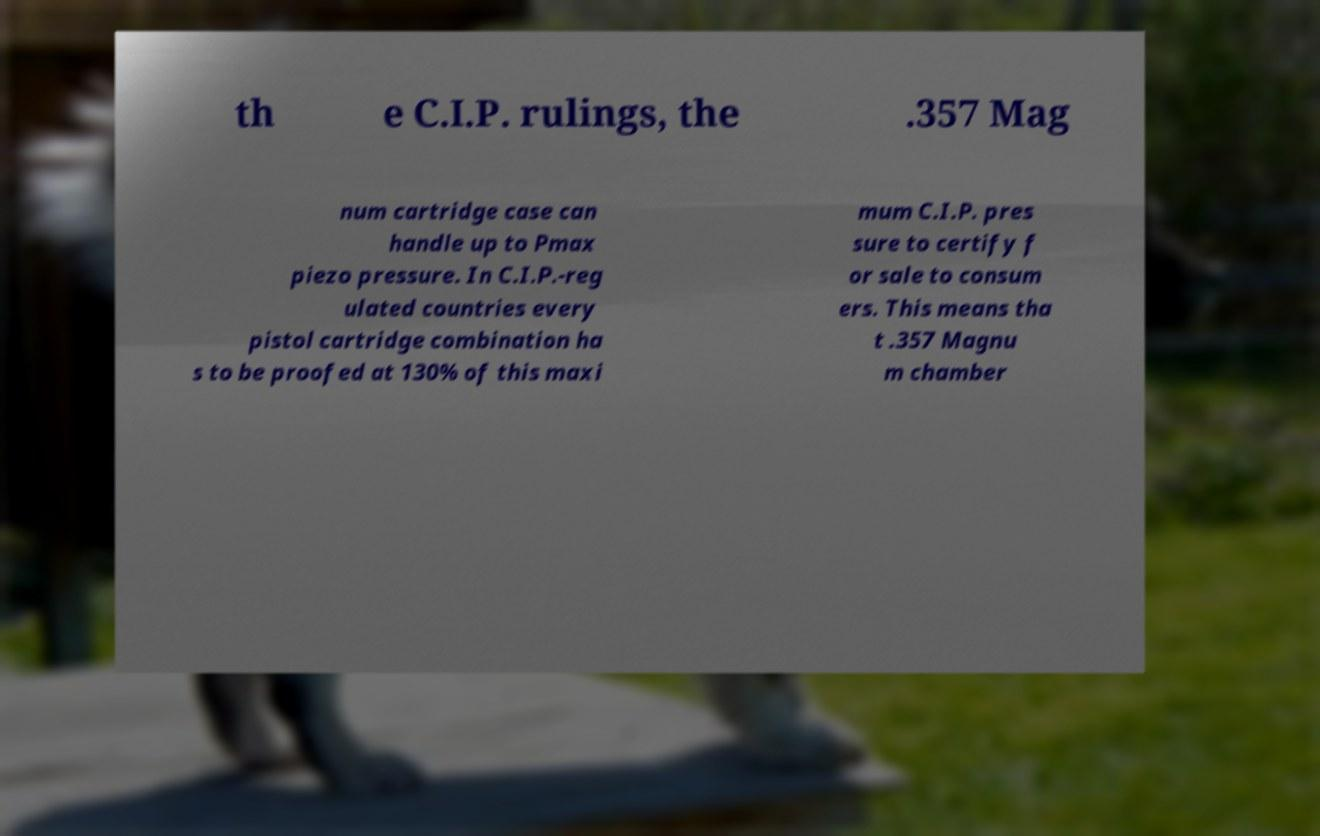For documentation purposes, I need the text within this image transcribed. Could you provide that? th e C.I.P. rulings, the .357 Mag num cartridge case can handle up to Pmax piezo pressure. In C.I.P.-reg ulated countries every pistol cartridge combination ha s to be proofed at 130% of this maxi mum C.I.P. pres sure to certify f or sale to consum ers. This means tha t .357 Magnu m chamber 